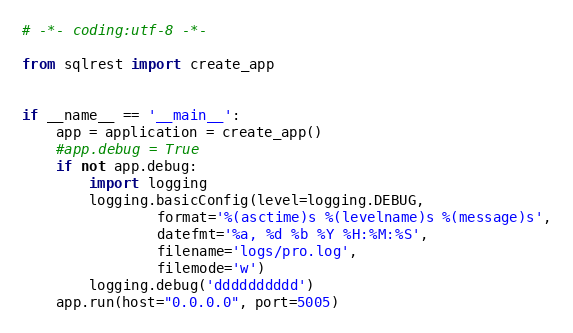<code> <loc_0><loc_0><loc_500><loc_500><_Python_># -*- coding:utf-8 -*-

from sqlrest import create_app


if __name__ == '__main__':
    app = application = create_app()
    #app.debug = True 
    if not app.debug:
        import logging
        logging.basicConfig(level=logging.DEBUG,
                format='%(asctime)s %(levelname)s %(message)s',
                datefmt='%a, %d %b %Y %H:%M:%S',
                filename='logs/pro.log',
                filemode='w')
        logging.debug('dddddddddd')
    app.run(host="0.0.0.0", port=5005)
</code> 